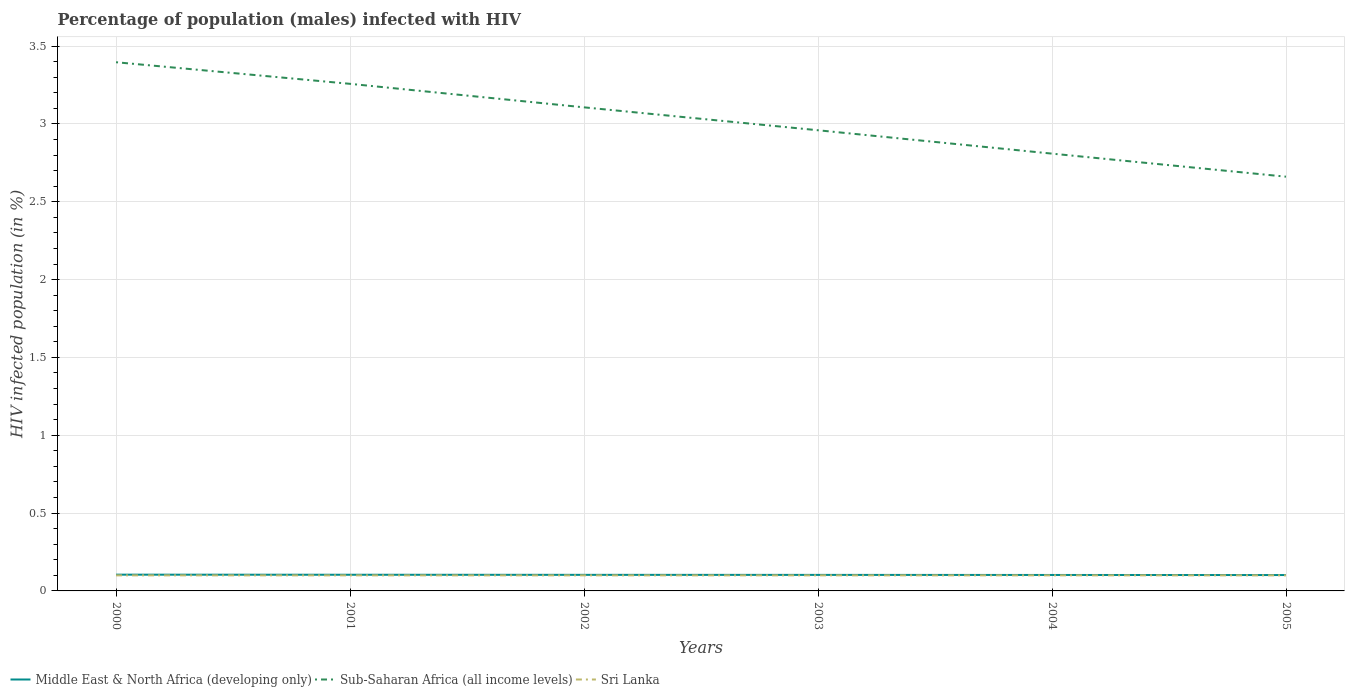How many different coloured lines are there?
Provide a succinct answer. 3. Across all years, what is the maximum percentage of HIV infected male population in Sri Lanka?
Your answer should be very brief. 0.1. What is the total percentage of HIV infected male population in Sub-Saharan Africa (all income levels) in the graph?
Offer a very short reply. 0.15. What is the difference between the highest and the second highest percentage of HIV infected male population in Middle East & North Africa (developing only)?
Your answer should be very brief. 0. What is the difference between the highest and the lowest percentage of HIV infected male population in Middle East & North Africa (developing only)?
Your response must be concise. 3. Does the graph contain grids?
Give a very brief answer. Yes. Where does the legend appear in the graph?
Provide a short and direct response. Bottom left. How many legend labels are there?
Your response must be concise. 3. What is the title of the graph?
Keep it short and to the point. Percentage of population (males) infected with HIV. Does "Fragile and conflict affected situations" appear as one of the legend labels in the graph?
Offer a very short reply. No. What is the label or title of the X-axis?
Give a very brief answer. Years. What is the label or title of the Y-axis?
Keep it short and to the point. HIV infected population (in %). What is the HIV infected population (in %) in Middle East & North Africa (developing only) in 2000?
Your answer should be very brief. 0.1. What is the HIV infected population (in %) in Sub-Saharan Africa (all income levels) in 2000?
Your answer should be compact. 3.4. What is the HIV infected population (in %) in Middle East & North Africa (developing only) in 2001?
Ensure brevity in your answer.  0.1. What is the HIV infected population (in %) of Sub-Saharan Africa (all income levels) in 2001?
Provide a short and direct response. 3.26. What is the HIV infected population (in %) of Middle East & North Africa (developing only) in 2002?
Your answer should be compact. 0.1. What is the HIV infected population (in %) of Sub-Saharan Africa (all income levels) in 2002?
Keep it short and to the point. 3.11. What is the HIV infected population (in %) in Sri Lanka in 2002?
Your response must be concise. 0.1. What is the HIV infected population (in %) in Middle East & North Africa (developing only) in 2003?
Provide a succinct answer. 0.1. What is the HIV infected population (in %) in Sub-Saharan Africa (all income levels) in 2003?
Your answer should be compact. 2.96. What is the HIV infected population (in %) of Middle East & North Africa (developing only) in 2004?
Make the answer very short. 0.1. What is the HIV infected population (in %) of Sub-Saharan Africa (all income levels) in 2004?
Ensure brevity in your answer.  2.81. What is the HIV infected population (in %) in Middle East & North Africa (developing only) in 2005?
Ensure brevity in your answer.  0.1. What is the HIV infected population (in %) in Sub-Saharan Africa (all income levels) in 2005?
Your answer should be very brief. 2.66. Across all years, what is the maximum HIV infected population (in %) of Middle East & North Africa (developing only)?
Your answer should be very brief. 0.1. Across all years, what is the maximum HIV infected population (in %) in Sub-Saharan Africa (all income levels)?
Your response must be concise. 3.4. Across all years, what is the maximum HIV infected population (in %) of Sri Lanka?
Your answer should be compact. 0.1. Across all years, what is the minimum HIV infected population (in %) in Middle East & North Africa (developing only)?
Give a very brief answer. 0.1. Across all years, what is the minimum HIV infected population (in %) of Sub-Saharan Africa (all income levels)?
Offer a very short reply. 2.66. Across all years, what is the minimum HIV infected population (in %) of Sri Lanka?
Your answer should be very brief. 0.1. What is the total HIV infected population (in %) of Middle East & North Africa (developing only) in the graph?
Give a very brief answer. 0.62. What is the total HIV infected population (in %) in Sub-Saharan Africa (all income levels) in the graph?
Give a very brief answer. 18.19. What is the difference between the HIV infected population (in %) of Middle East & North Africa (developing only) in 2000 and that in 2001?
Provide a succinct answer. 0. What is the difference between the HIV infected population (in %) in Sub-Saharan Africa (all income levels) in 2000 and that in 2001?
Ensure brevity in your answer.  0.14. What is the difference between the HIV infected population (in %) in Middle East & North Africa (developing only) in 2000 and that in 2002?
Offer a very short reply. 0. What is the difference between the HIV infected population (in %) in Sub-Saharan Africa (all income levels) in 2000 and that in 2002?
Offer a very short reply. 0.29. What is the difference between the HIV infected population (in %) in Middle East & North Africa (developing only) in 2000 and that in 2003?
Your answer should be very brief. 0. What is the difference between the HIV infected population (in %) of Sub-Saharan Africa (all income levels) in 2000 and that in 2003?
Offer a very short reply. 0.44. What is the difference between the HIV infected population (in %) of Sri Lanka in 2000 and that in 2003?
Offer a terse response. 0. What is the difference between the HIV infected population (in %) of Middle East & North Africa (developing only) in 2000 and that in 2004?
Give a very brief answer. 0. What is the difference between the HIV infected population (in %) in Sub-Saharan Africa (all income levels) in 2000 and that in 2004?
Your response must be concise. 0.59. What is the difference between the HIV infected population (in %) of Sri Lanka in 2000 and that in 2004?
Make the answer very short. 0. What is the difference between the HIV infected population (in %) of Middle East & North Africa (developing only) in 2000 and that in 2005?
Offer a terse response. 0. What is the difference between the HIV infected population (in %) in Sub-Saharan Africa (all income levels) in 2000 and that in 2005?
Provide a short and direct response. 0.74. What is the difference between the HIV infected population (in %) in Middle East & North Africa (developing only) in 2001 and that in 2002?
Provide a short and direct response. 0. What is the difference between the HIV infected population (in %) in Sub-Saharan Africa (all income levels) in 2001 and that in 2002?
Your answer should be compact. 0.15. What is the difference between the HIV infected population (in %) of Sri Lanka in 2001 and that in 2002?
Offer a terse response. 0. What is the difference between the HIV infected population (in %) of Middle East & North Africa (developing only) in 2001 and that in 2003?
Make the answer very short. 0. What is the difference between the HIV infected population (in %) in Sub-Saharan Africa (all income levels) in 2001 and that in 2003?
Offer a very short reply. 0.3. What is the difference between the HIV infected population (in %) of Sri Lanka in 2001 and that in 2003?
Your answer should be very brief. 0. What is the difference between the HIV infected population (in %) in Middle East & North Africa (developing only) in 2001 and that in 2004?
Offer a terse response. 0. What is the difference between the HIV infected population (in %) of Sub-Saharan Africa (all income levels) in 2001 and that in 2004?
Provide a succinct answer. 0.45. What is the difference between the HIV infected population (in %) of Middle East & North Africa (developing only) in 2001 and that in 2005?
Your response must be concise. 0. What is the difference between the HIV infected population (in %) of Sub-Saharan Africa (all income levels) in 2001 and that in 2005?
Your answer should be compact. 0.6. What is the difference between the HIV infected population (in %) of Sub-Saharan Africa (all income levels) in 2002 and that in 2003?
Provide a succinct answer. 0.15. What is the difference between the HIV infected population (in %) of Sri Lanka in 2002 and that in 2003?
Make the answer very short. 0. What is the difference between the HIV infected population (in %) of Middle East & North Africa (developing only) in 2002 and that in 2004?
Ensure brevity in your answer.  0. What is the difference between the HIV infected population (in %) in Sub-Saharan Africa (all income levels) in 2002 and that in 2004?
Provide a succinct answer. 0.3. What is the difference between the HIV infected population (in %) of Middle East & North Africa (developing only) in 2002 and that in 2005?
Keep it short and to the point. 0. What is the difference between the HIV infected population (in %) of Sub-Saharan Africa (all income levels) in 2002 and that in 2005?
Your answer should be very brief. 0.45. What is the difference between the HIV infected population (in %) in Middle East & North Africa (developing only) in 2003 and that in 2004?
Your response must be concise. 0. What is the difference between the HIV infected population (in %) in Sub-Saharan Africa (all income levels) in 2003 and that in 2004?
Offer a terse response. 0.15. What is the difference between the HIV infected population (in %) of Sri Lanka in 2003 and that in 2004?
Offer a very short reply. 0. What is the difference between the HIV infected population (in %) in Middle East & North Africa (developing only) in 2003 and that in 2005?
Provide a succinct answer. 0. What is the difference between the HIV infected population (in %) of Sub-Saharan Africa (all income levels) in 2003 and that in 2005?
Make the answer very short. 0.3. What is the difference between the HIV infected population (in %) of Sri Lanka in 2003 and that in 2005?
Provide a succinct answer. 0. What is the difference between the HIV infected population (in %) of Middle East & North Africa (developing only) in 2004 and that in 2005?
Your response must be concise. 0. What is the difference between the HIV infected population (in %) of Sub-Saharan Africa (all income levels) in 2004 and that in 2005?
Ensure brevity in your answer.  0.15. What is the difference between the HIV infected population (in %) in Middle East & North Africa (developing only) in 2000 and the HIV infected population (in %) in Sub-Saharan Africa (all income levels) in 2001?
Make the answer very short. -3.15. What is the difference between the HIV infected population (in %) of Middle East & North Africa (developing only) in 2000 and the HIV infected population (in %) of Sri Lanka in 2001?
Keep it short and to the point. 0. What is the difference between the HIV infected population (in %) in Sub-Saharan Africa (all income levels) in 2000 and the HIV infected population (in %) in Sri Lanka in 2001?
Provide a succinct answer. 3.3. What is the difference between the HIV infected population (in %) of Middle East & North Africa (developing only) in 2000 and the HIV infected population (in %) of Sub-Saharan Africa (all income levels) in 2002?
Make the answer very short. -3. What is the difference between the HIV infected population (in %) of Middle East & North Africa (developing only) in 2000 and the HIV infected population (in %) of Sri Lanka in 2002?
Ensure brevity in your answer.  0. What is the difference between the HIV infected population (in %) of Sub-Saharan Africa (all income levels) in 2000 and the HIV infected population (in %) of Sri Lanka in 2002?
Your answer should be very brief. 3.3. What is the difference between the HIV infected population (in %) of Middle East & North Africa (developing only) in 2000 and the HIV infected population (in %) of Sub-Saharan Africa (all income levels) in 2003?
Make the answer very short. -2.85. What is the difference between the HIV infected population (in %) of Middle East & North Africa (developing only) in 2000 and the HIV infected population (in %) of Sri Lanka in 2003?
Provide a succinct answer. 0. What is the difference between the HIV infected population (in %) of Sub-Saharan Africa (all income levels) in 2000 and the HIV infected population (in %) of Sri Lanka in 2003?
Offer a terse response. 3.3. What is the difference between the HIV infected population (in %) in Middle East & North Africa (developing only) in 2000 and the HIV infected population (in %) in Sub-Saharan Africa (all income levels) in 2004?
Your answer should be very brief. -2.7. What is the difference between the HIV infected population (in %) of Middle East & North Africa (developing only) in 2000 and the HIV infected population (in %) of Sri Lanka in 2004?
Make the answer very short. 0. What is the difference between the HIV infected population (in %) of Sub-Saharan Africa (all income levels) in 2000 and the HIV infected population (in %) of Sri Lanka in 2004?
Keep it short and to the point. 3.3. What is the difference between the HIV infected population (in %) in Middle East & North Africa (developing only) in 2000 and the HIV infected population (in %) in Sub-Saharan Africa (all income levels) in 2005?
Your answer should be compact. -2.56. What is the difference between the HIV infected population (in %) in Middle East & North Africa (developing only) in 2000 and the HIV infected population (in %) in Sri Lanka in 2005?
Offer a very short reply. 0. What is the difference between the HIV infected population (in %) in Sub-Saharan Africa (all income levels) in 2000 and the HIV infected population (in %) in Sri Lanka in 2005?
Your answer should be compact. 3.3. What is the difference between the HIV infected population (in %) in Middle East & North Africa (developing only) in 2001 and the HIV infected population (in %) in Sub-Saharan Africa (all income levels) in 2002?
Your answer should be compact. -3. What is the difference between the HIV infected population (in %) in Middle East & North Africa (developing only) in 2001 and the HIV infected population (in %) in Sri Lanka in 2002?
Your answer should be very brief. 0. What is the difference between the HIV infected population (in %) of Sub-Saharan Africa (all income levels) in 2001 and the HIV infected population (in %) of Sri Lanka in 2002?
Offer a terse response. 3.16. What is the difference between the HIV infected population (in %) of Middle East & North Africa (developing only) in 2001 and the HIV infected population (in %) of Sub-Saharan Africa (all income levels) in 2003?
Your response must be concise. -2.86. What is the difference between the HIV infected population (in %) of Middle East & North Africa (developing only) in 2001 and the HIV infected population (in %) of Sri Lanka in 2003?
Your response must be concise. 0. What is the difference between the HIV infected population (in %) of Sub-Saharan Africa (all income levels) in 2001 and the HIV infected population (in %) of Sri Lanka in 2003?
Ensure brevity in your answer.  3.16. What is the difference between the HIV infected population (in %) of Middle East & North Africa (developing only) in 2001 and the HIV infected population (in %) of Sub-Saharan Africa (all income levels) in 2004?
Your answer should be very brief. -2.71. What is the difference between the HIV infected population (in %) in Middle East & North Africa (developing only) in 2001 and the HIV infected population (in %) in Sri Lanka in 2004?
Make the answer very short. 0. What is the difference between the HIV infected population (in %) of Sub-Saharan Africa (all income levels) in 2001 and the HIV infected population (in %) of Sri Lanka in 2004?
Your answer should be very brief. 3.16. What is the difference between the HIV infected population (in %) of Middle East & North Africa (developing only) in 2001 and the HIV infected population (in %) of Sub-Saharan Africa (all income levels) in 2005?
Your answer should be very brief. -2.56. What is the difference between the HIV infected population (in %) in Middle East & North Africa (developing only) in 2001 and the HIV infected population (in %) in Sri Lanka in 2005?
Offer a very short reply. 0. What is the difference between the HIV infected population (in %) in Sub-Saharan Africa (all income levels) in 2001 and the HIV infected population (in %) in Sri Lanka in 2005?
Give a very brief answer. 3.16. What is the difference between the HIV infected population (in %) of Middle East & North Africa (developing only) in 2002 and the HIV infected population (in %) of Sub-Saharan Africa (all income levels) in 2003?
Offer a terse response. -2.86. What is the difference between the HIV infected population (in %) in Middle East & North Africa (developing only) in 2002 and the HIV infected population (in %) in Sri Lanka in 2003?
Offer a terse response. 0. What is the difference between the HIV infected population (in %) of Sub-Saharan Africa (all income levels) in 2002 and the HIV infected population (in %) of Sri Lanka in 2003?
Your answer should be compact. 3.01. What is the difference between the HIV infected population (in %) of Middle East & North Africa (developing only) in 2002 and the HIV infected population (in %) of Sub-Saharan Africa (all income levels) in 2004?
Your answer should be compact. -2.71. What is the difference between the HIV infected population (in %) in Middle East & North Africa (developing only) in 2002 and the HIV infected population (in %) in Sri Lanka in 2004?
Provide a short and direct response. 0. What is the difference between the HIV infected population (in %) of Sub-Saharan Africa (all income levels) in 2002 and the HIV infected population (in %) of Sri Lanka in 2004?
Ensure brevity in your answer.  3.01. What is the difference between the HIV infected population (in %) in Middle East & North Africa (developing only) in 2002 and the HIV infected population (in %) in Sub-Saharan Africa (all income levels) in 2005?
Your answer should be compact. -2.56. What is the difference between the HIV infected population (in %) in Middle East & North Africa (developing only) in 2002 and the HIV infected population (in %) in Sri Lanka in 2005?
Keep it short and to the point. 0. What is the difference between the HIV infected population (in %) in Sub-Saharan Africa (all income levels) in 2002 and the HIV infected population (in %) in Sri Lanka in 2005?
Ensure brevity in your answer.  3.01. What is the difference between the HIV infected population (in %) of Middle East & North Africa (developing only) in 2003 and the HIV infected population (in %) of Sub-Saharan Africa (all income levels) in 2004?
Ensure brevity in your answer.  -2.71. What is the difference between the HIV infected population (in %) of Middle East & North Africa (developing only) in 2003 and the HIV infected population (in %) of Sri Lanka in 2004?
Provide a short and direct response. 0. What is the difference between the HIV infected population (in %) of Sub-Saharan Africa (all income levels) in 2003 and the HIV infected population (in %) of Sri Lanka in 2004?
Make the answer very short. 2.86. What is the difference between the HIV infected population (in %) of Middle East & North Africa (developing only) in 2003 and the HIV infected population (in %) of Sub-Saharan Africa (all income levels) in 2005?
Keep it short and to the point. -2.56. What is the difference between the HIV infected population (in %) of Middle East & North Africa (developing only) in 2003 and the HIV infected population (in %) of Sri Lanka in 2005?
Provide a short and direct response. 0. What is the difference between the HIV infected population (in %) in Sub-Saharan Africa (all income levels) in 2003 and the HIV infected population (in %) in Sri Lanka in 2005?
Provide a succinct answer. 2.86. What is the difference between the HIV infected population (in %) of Middle East & North Africa (developing only) in 2004 and the HIV infected population (in %) of Sub-Saharan Africa (all income levels) in 2005?
Offer a terse response. -2.56. What is the difference between the HIV infected population (in %) in Middle East & North Africa (developing only) in 2004 and the HIV infected population (in %) in Sri Lanka in 2005?
Provide a succinct answer. 0. What is the difference between the HIV infected population (in %) of Sub-Saharan Africa (all income levels) in 2004 and the HIV infected population (in %) of Sri Lanka in 2005?
Keep it short and to the point. 2.71. What is the average HIV infected population (in %) of Middle East & North Africa (developing only) per year?
Offer a terse response. 0.1. What is the average HIV infected population (in %) in Sub-Saharan Africa (all income levels) per year?
Your response must be concise. 3.03. What is the average HIV infected population (in %) of Sri Lanka per year?
Offer a very short reply. 0.1. In the year 2000, what is the difference between the HIV infected population (in %) of Middle East & North Africa (developing only) and HIV infected population (in %) of Sub-Saharan Africa (all income levels)?
Provide a short and direct response. -3.29. In the year 2000, what is the difference between the HIV infected population (in %) in Middle East & North Africa (developing only) and HIV infected population (in %) in Sri Lanka?
Your answer should be compact. 0. In the year 2000, what is the difference between the HIV infected population (in %) of Sub-Saharan Africa (all income levels) and HIV infected population (in %) of Sri Lanka?
Your response must be concise. 3.3. In the year 2001, what is the difference between the HIV infected population (in %) in Middle East & North Africa (developing only) and HIV infected population (in %) in Sub-Saharan Africa (all income levels)?
Offer a terse response. -3.15. In the year 2001, what is the difference between the HIV infected population (in %) in Middle East & North Africa (developing only) and HIV infected population (in %) in Sri Lanka?
Your answer should be very brief. 0. In the year 2001, what is the difference between the HIV infected population (in %) of Sub-Saharan Africa (all income levels) and HIV infected population (in %) of Sri Lanka?
Ensure brevity in your answer.  3.16. In the year 2002, what is the difference between the HIV infected population (in %) in Middle East & North Africa (developing only) and HIV infected population (in %) in Sub-Saharan Africa (all income levels)?
Your answer should be compact. -3. In the year 2002, what is the difference between the HIV infected population (in %) of Middle East & North Africa (developing only) and HIV infected population (in %) of Sri Lanka?
Give a very brief answer. 0. In the year 2002, what is the difference between the HIV infected population (in %) in Sub-Saharan Africa (all income levels) and HIV infected population (in %) in Sri Lanka?
Your answer should be compact. 3.01. In the year 2003, what is the difference between the HIV infected population (in %) of Middle East & North Africa (developing only) and HIV infected population (in %) of Sub-Saharan Africa (all income levels)?
Your answer should be compact. -2.86. In the year 2003, what is the difference between the HIV infected population (in %) of Middle East & North Africa (developing only) and HIV infected population (in %) of Sri Lanka?
Provide a short and direct response. 0. In the year 2003, what is the difference between the HIV infected population (in %) in Sub-Saharan Africa (all income levels) and HIV infected population (in %) in Sri Lanka?
Make the answer very short. 2.86. In the year 2004, what is the difference between the HIV infected population (in %) in Middle East & North Africa (developing only) and HIV infected population (in %) in Sub-Saharan Africa (all income levels)?
Your response must be concise. -2.71. In the year 2004, what is the difference between the HIV infected population (in %) in Middle East & North Africa (developing only) and HIV infected population (in %) in Sri Lanka?
Keep it short and to the point. 0. In the year 2004, what is the difference between the HIV infected population (in %) in Sub-Saharan Africa (all income levels) and HIV infected population (in %) in Sri Lanka?
Offer a terse response. 2.71. In the year 2005, what is the difference between the HIV infected population (in %) of Middle East & North Africa (developing only) and HIV infected population (in %) of Sub-Saharan Africa (all income levels)?
Your answer should be compact. -2.56. In the year 2005, what is the difference between the HIV infected population (in %) of Middle East & North Africa (developing only) and HIV infected population (in %) of Sri Lanka?
Offer a terse response. 0. In the year 2005, what is the difference between the HIV infected population (in %) of Sub-Saharan Africa (all income levels) and HIV infected population (in %) of Sri Lanka?
Give a very brief answer. 2.56. What is the ratio of the HIV infected population (in %) in Sub-Saharan Africa (all income levels) in 2000 to that in 2001?
Offer a very short reply. 1.04. What is the ratio of the HIV infected population (in %) of Sri Lanka in 2000 to that in 2001?
Your response must be concise. 1. What is the ratio of the HIV infected population (in %) of Middle East & North Africa (developing only) in 2000 to that in 2002?
Give a very brief answer. 1.01. What is the ratio of the HIV infected population (in %) of Sub-Saharan Africa (all income levels) in 2000 to that in 2002?
Provide a succinct answer. 1.09. What is the ratio of the HIV infected population (in %) of Sri Lanka in 2000 to that in 2002?
Keep it short and to the point. 1. What is the ratio of the HIV infected population (in %) in Sub-Saharan Africa (all income levels) in 2000 to that in 2003?
Your answer should be very brief. 1.15. What is the ratio of the HIV infected population (in %) in Sri Lanka in 2000 to that in 2003?
Your answer should be very brief. 1. What is the ratio of the HIV infected population (in %) in Middle East & North Africa (developing only) in 2000 to that in 2004?
Ensure brevity in your answer.  1.02. What is the ratio of the HIV infected population (in %) in Sub-Saharan Africa (all income levels) in 2000 to that in 2004?
Your response must be concise. 1.21. What is the ratio of the HIV infected population (in %) of Middle East & North Africa (developing only) in 2000 to that in 2005?
Offer a very short reply. 1.02. What is the ratio of the HIV infected population (in %) in Sub-Saharan Africa (all income levels) in 2000 to that in 2005?
Provide a short and direct response. 1.28. What is the ratio of the HIV infected population (in %) in Sri Lanka in 2000 to that in 2005?
Ensure brevity in your answer.  1. What is the ratio of the HIV infected population (in %) in Middle East & North Africa (developing only) in 2001 to that in 2002?
Keep it short and to the point. 1.01. What is the ratio of the HIV infected population (in %) in Sub-Saharan Africa (all income levels) in 2001 to that in 2002?
Offer a terse response. 1.05. What is the ratio of the HIV infected population (in %) in Sri Lanka in 2001 to that in 2002?
Your answer should be very brief. 1. What is the ratio of the HIV infected population (in %) in Middle East & North Africa (developing only) in 2001 to that in 2003?
Offer a terse response. 1.01. What is the ratio of the HIV infected population (in %) of Sub-Saharan Africa (all income levels) in 2001 to that in 2003?
Offer a terse response. 1.1. What is the ratio of the HIV infected population (in %) of Sri Lanka in 2001 to that in 2003?
Make the answer very short. 1. What is the ratio of the HIV infected population (in %) in Middle East & North Africa (developing only) in 2001 to that in 2004?
Give a very brief answer. 1.01. What is the ratio of the HIV infected population (in %) in Sub-Saharan Africa (all income levels) in 2001 to that in 2004?
Ensure brevity in your answer.  1.16. What is the ratio of the HIV infected population (in %) of Sri Lanka in 2001 to that in 2004?
Offer a terse response. 1. What is the ratio of the HIV infected population (in %) in Middle East & North Africa (developing only) in 2001 to that in 2005?
Your answer should be very brief. 1.02. What is the ratio of the HIV infected population (in %) in Sub-Saharan Africa (all income levels) in 2001 to that in 2005?
Keep it short and to the point. 1.22. What is the ratio of the HIV infected population (in %) in Sri Lanka in 2001 to that in 2005?
Provide a short and direct response. 1. What is the ratio of the HIV infected population (in %) of Middle East & North Africa (developing only) in 2002 to that in 2003?
Your response must be concise. 1. What is the ratio of the HIV infected population (in %) of Sub-Saharan Africa (all income levels) in 2002 to that in 2003?
Your response must be concise. 1.05. What is the ratio of the HIV infected population (in %) in Sri Lanka in 2002 to that in 2003?
Your response must be concise. 1. What is the ratio of the HIV infected population (in %) of Middle East & North Africa (developing only) in 2002 to that in 2004?
Keep it short and to the point. 1.01. What is the ratio of the HIV infected population (in %) in Sub-Saharan Africa (all income levels) in 2002 to that in 2004?
Make the answer very short. 1.11. What is the ratio of the HIV infected population (in %) of Sri Lanka in 2002 to that in 2004?
Your answer should be compact. 1. What is the ratio of the HIV infected population (in %) of Middle East & North Africa (developing only) in 2002 to that in 2005?
Your answer should be very brief. 1.01. What is the ratio of the HIV infected population (in %) in Sub-Saharan Africa (all income levels) in 2002 to that in 2005?
Offer a terse response. 1.17. What is the ratio of the HIV infected population (in %) of Sri Lanka in 2002 to that in 2005?
Make the answer very short. 1. What is the ratio of the HIV infected population (in %) of Sub-Saharan Africa (all income levels) in 2003 to that in 2004?
Offer a terse response. 1.05. What is the ratio of the HIV infected population (in %) in Sri Lanka in 2003 to that in 2004?
Provide a short and direct response. 1. What is the ratio of the HIV infected population (in %) of Middle East & North Africa (developing only) in 2003 to that in 2005?
Ensure brevity in your answer.  1.01. What is the ratio of the HIV infected population (in %) in Sub-Saharan Africa (all income levels) in 2003 to that in 2005?
Your answer should be compact. 1.11. What is the ratio of the HIV infected population (in %) of Middle East & North Africa (developing only) in 2004 to that in 2005?
Your response must be concise. 1.01. What is the ratio of the HIV infected population (in %) in Sub-Saharan Africa (all income levels) in 2004 to that in 2005?
Offer a very short reply. 1.06. What is the difference between the highest and the second highest HIV infected population (in %) of Middle East & North Africa (developing only)?
Provide a succinct answer. 0. What is the difference between the highest and the second highest HIV infected population (in %) in Sub-Saharan Africa (all income levels)?
Your response must be concise. 0.14. What is the difference between the highest and the lowest HIV infected population (in %) of Middle East & North Africa (developing only)?
Ensure brevity in your answer.  0. What is the difference between the highest and the lowest HIV infected population (in %) in Sub-Saharan Africa (all income levels)?
Provide a short and direct response. 0.74. What is the difference between the highest and the lowest HIV infected population (in %) of Sri Lanka?
Give a very brief answer. 0. 